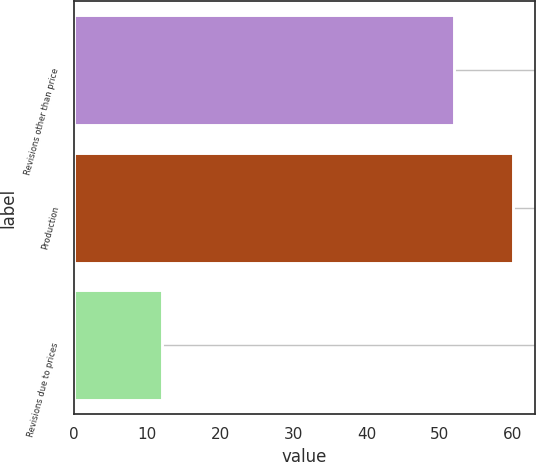Convert chart to OTSL. <chart><loc_0><loc_0><loc_500><loc_500><bar_chart><fcel>Revisions other than price<fcel>Production<fcel>Revisions due to prices<nl><fcel>52<fcel>60<fcel>12<nl></chart> 